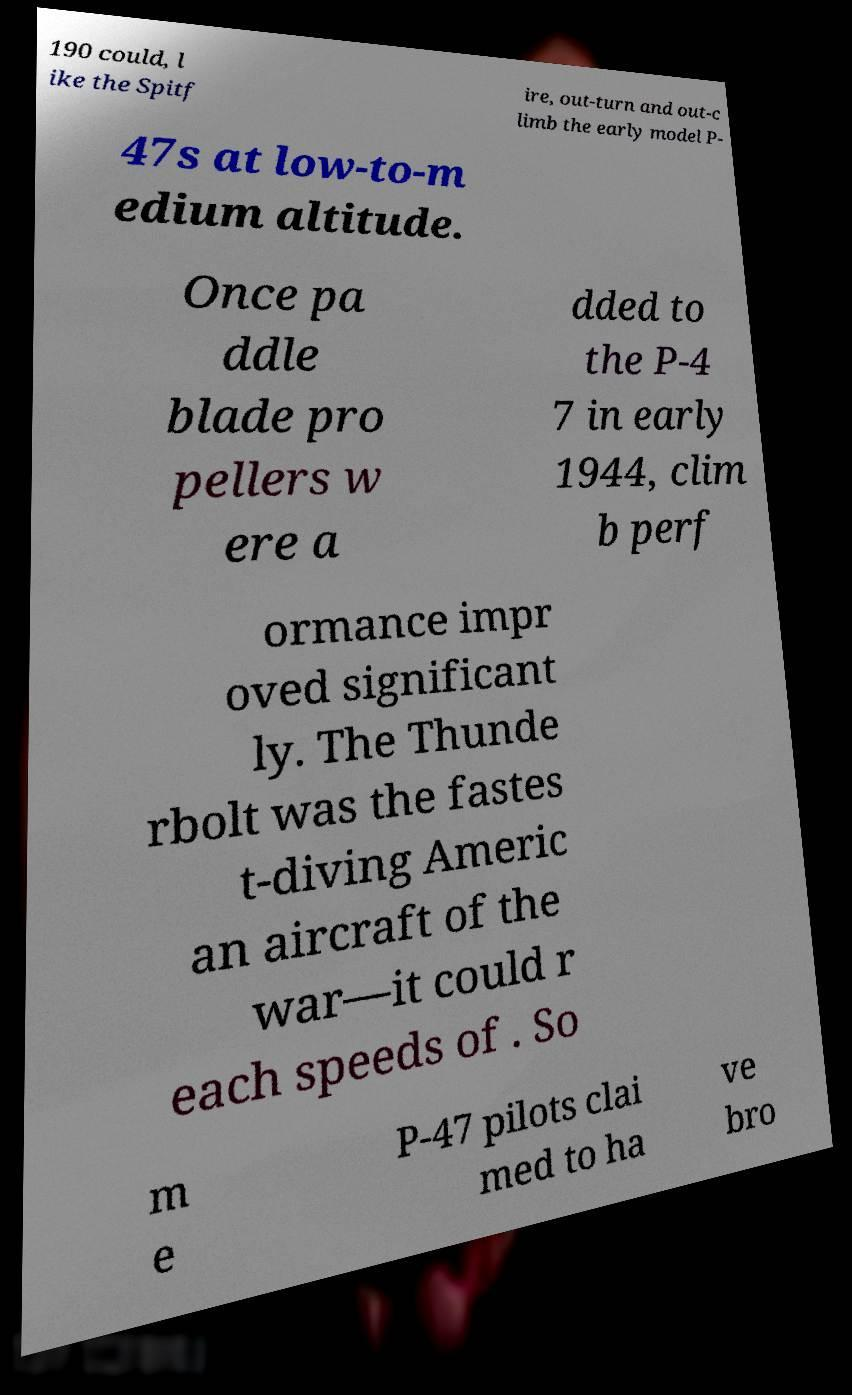Please identify and transcribe the text found in this image. 190 could, l ike the Spitf ire, out-turn and out-c limb the early model P- 47s at low-to-m edium altitude. Once pa ddle blade pro pellers w ere a dded to the P-4 7 in early 1944, clim b perf ormance impr oved significant ly. The Thunde rbolt was the fastes t-diving Americ an aircraft of the war—it could r each speeds of . So m e P-47 pilots clai med to ha ve bro 